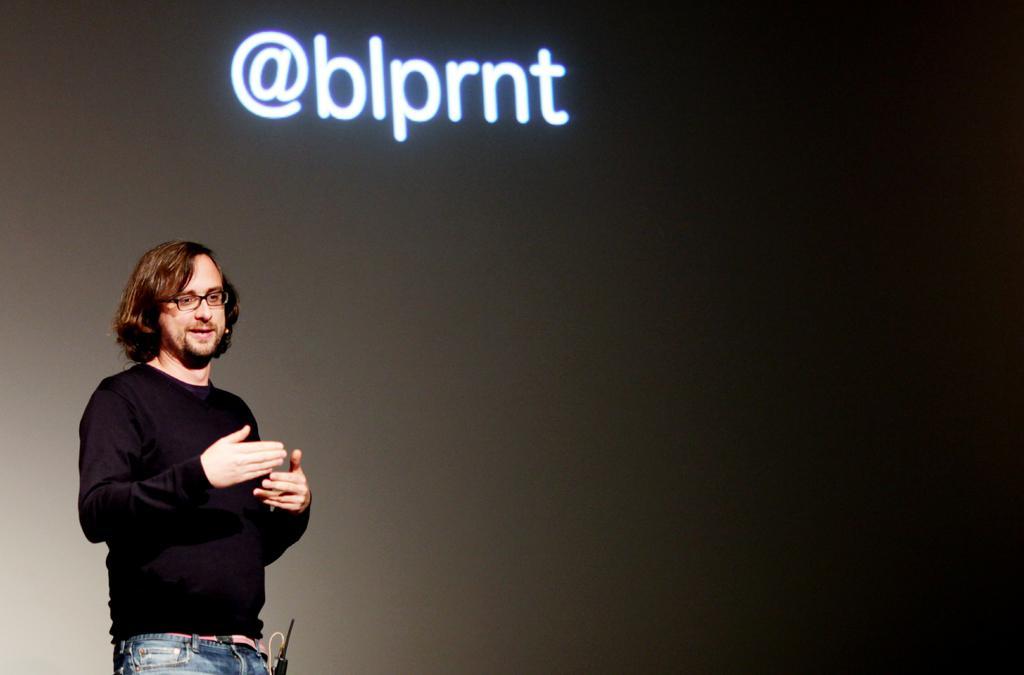Could you give a brief overview of what you see in this image? In the image there is a man, he giving a seminar, he is wearing a black shirt and behind the man there is a screen and something is being displayed on the screen. 